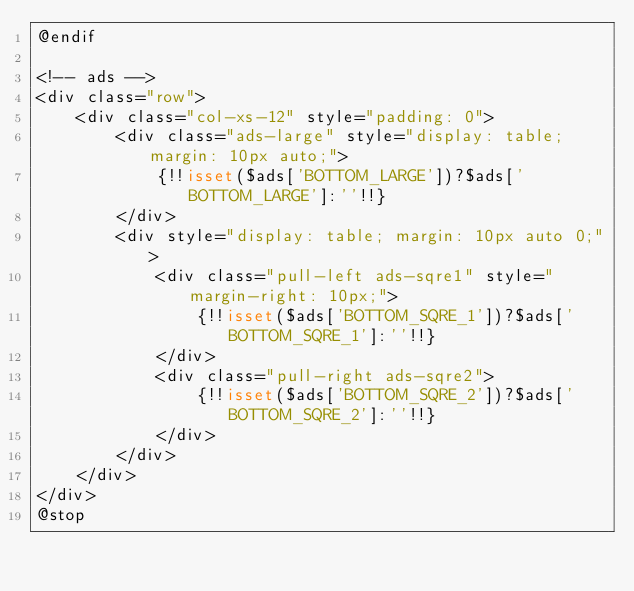Convert code to text. <code><loc_0><loc_0><loc_500><loc_500><_PHP_>@endif

<!-- ads -->
<div class="row">
    <div class="col-xs-12" style="padding: 0">
        <div class="ads-large" style="display: table; margin: 10px auto;">
            {!!isset($ads['BOTTOM_LARGE'])?$ads['BOTTOM_LARGE']:''!!}
        </div>
        <div style="display: table; margin: 10px auto 0;">
            <div class="pull-left ads-sqre1" style="margin-right: 10px;">
                {!!isset($ads['BOTTOM_SQRE_1'])?$ads['BOTTOM_SQRE_1']:''!!}
            </div>
            <div class="pull-right ads-sqre2">
                {!!isset($ads['BOTTOM_SQRE_2'])?$ads['BOTTOM_SQRE_2']:''!!}
            </div>
        </div>
    </div>
</div>
@stop

</code> 